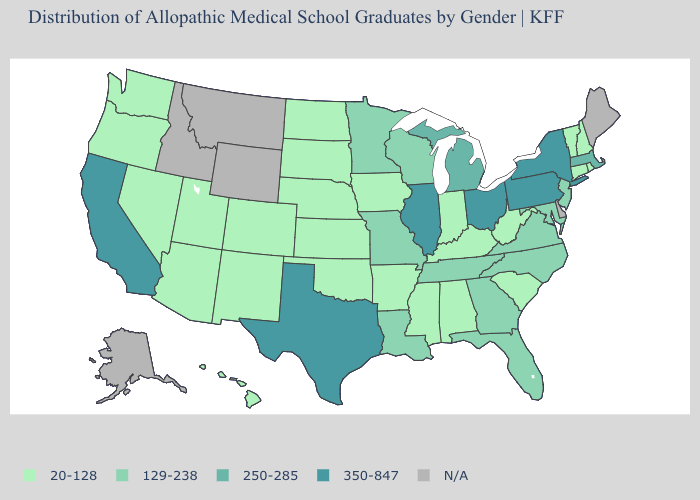Does the first symbol in the legend represent the smallest category?
Be succinct. Yes. What is the highest value in states that border Tennessee?
Keep it brief. 129-238. Name the states that have a value in the range 20-128?
Quick response, please. Alabama, Arizona, Arkansas, Colorado, Connecticut, Hawaii, Indiana, Iowa, Kansas, Kentucky, Mississippi, Nebraska, Nevada, New Hampshire, New Mexico, North Dakota, Oklahoma, Oregon, Rhode Island, South Carolina, South Dakota, Utah, Vermont, Washington, West Virginia. What is the value of Maine?
Be succinct. N/A. Among the states that border Ohio , which have the lowest value?
Write a very short answer. Indiana, Kentucky, West Virginia. Name the states that have a value in the range 350-847?
Keep it brief. California, Illinois, New York, Ohio, Pennsylvania, Texas. Which states have the highest value in the USA?
Answer briefly. California, Illinois, New York, Ohio, Pennsylvania, Texas. What is the value of Montana?
Give a very brief answer. N/A. Name the states that have a value in the range N/A?
Keep it brief. Alaska, Delaware, Idaho, Maine, Montana, Wyoming. Name the states that have a value in the range 250-285?
Be succinct. Massachusetts, Michigan. Which states have the highest value in the USA?
Short answer required. California, Illinois, New York, Ohio, Pennsylvania, Texas. Does California have the lowest value in the West?
Concise answer only. No. What is the value of Nevada?
Keep it brief. 20-128. Does Ohio have the highest value in the MidWest?
Give a very brief answer. Yes. Does Vermont have the lowest value in the USA?
Give a very brief answer. Yes. 